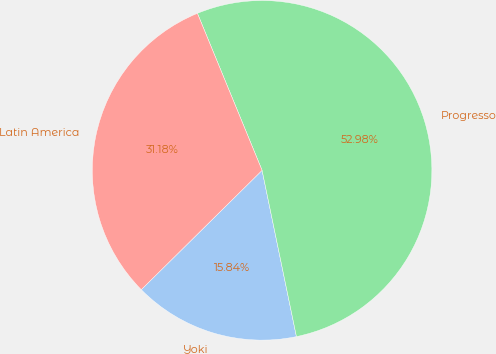Convert chart to OTSL. <chart><loc_0><loc_0><loc_500><loc_500><pie_chart><fcel>Yoki<fcel>Progresso<fcel>Latin America<nl><fcel>15.84%<fcel>52.97%<fcel>31.18%<nl></chart> 